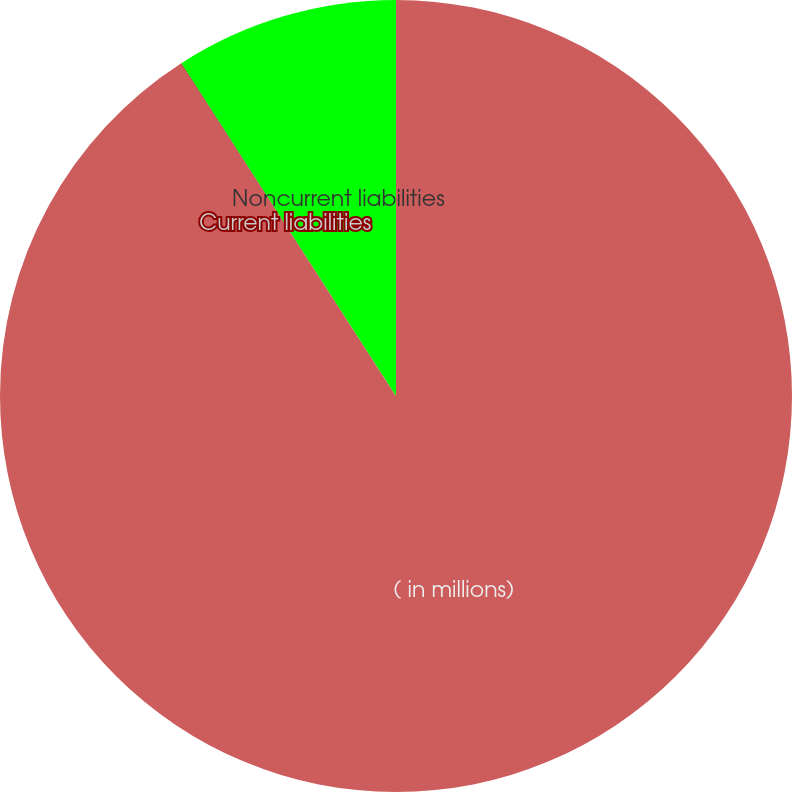Convert chart to OTSL. <chart><loc_0><loc_0><loc_500><loc_500><pie_chart><fcel>( in millions)<fcel>Current liabilities<fcel>Noncurrent liabilities<nl><fcel>90.85%<fcel>0.03%<fcel>9.11%<nl></chart> 